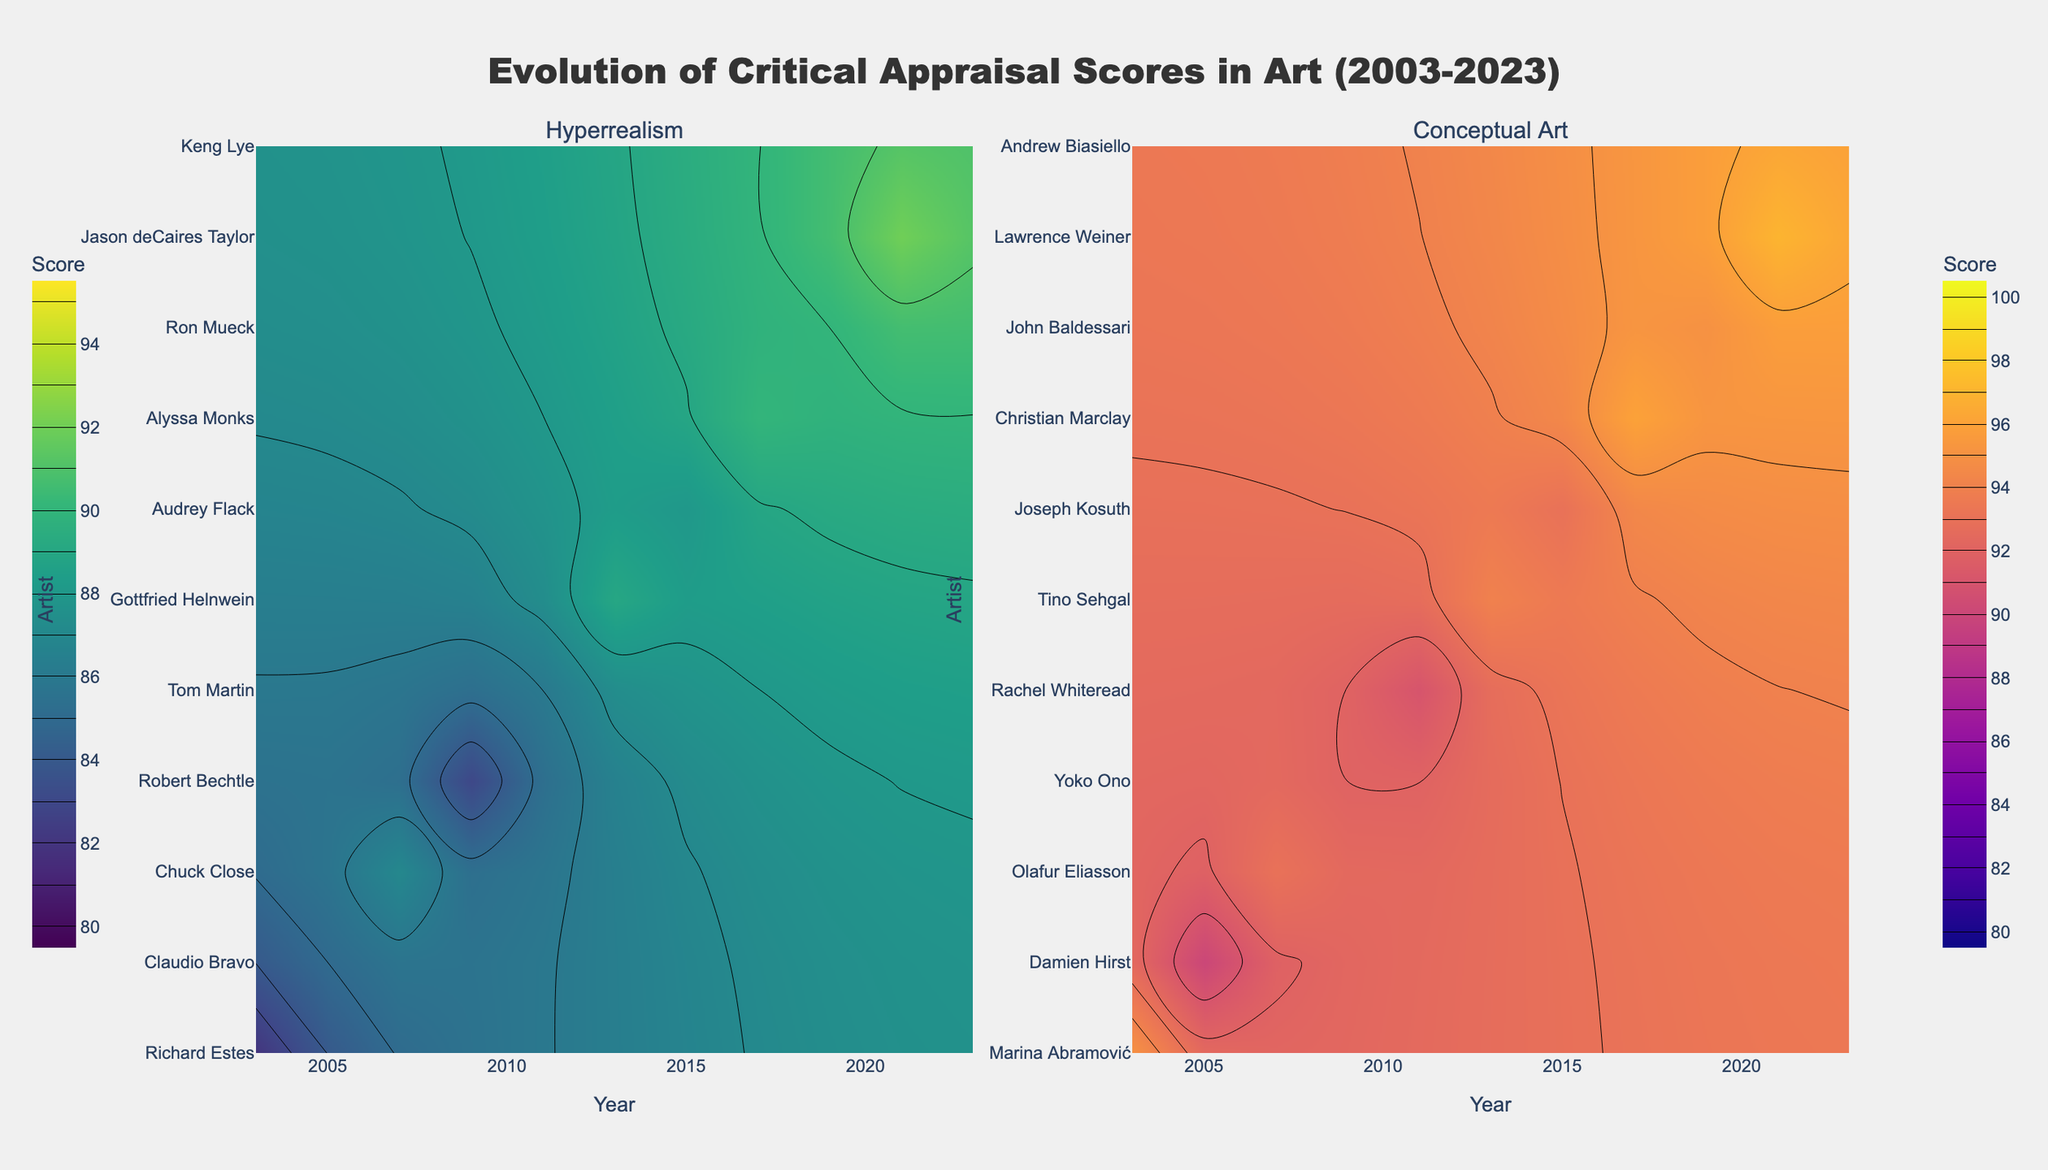What are the subplot titles in the figure? The subplot titles are present at the top of each subplot and they categorize the data into two types of art. The titles are clearly labeled and can be easily seen from the figure.
Answer: Hyperrealism and Conceptual Art What does the color scale represent in the Hyperrealism subplot? The color scale is located at the left side of the Hyperrealism subplot and indicates the range of critical appraisal scores. It shows that different shades represent different score values.
Answer: Critical appraisal scores Based on the contours, which Hyperrealism artist received the highest critical appraisal score and in which year? The contours in the Hyperrealism subplot allow us to identify the artist with the highest score by looking at the darkest area, indicating the highest score value.
Answer: Jason deCaires Taylor, 2021 Compare the overall trend of critical appraisal scores for Hyperrealism vs Conceptual Art from 2003 to 2023. Which art form tends to receive higher scores overall? Observing the color gradients and contour lines in both subplots, compare the coverage and intensity of higher score values. The Conceptual Art subplot has more intense colors in the higher range, indicating generally higher scores.
Answer: Conceptual Art What's the median score for the Hyperrealism art pieces in the figure? To determine the median score, find the middle value when the scores are arranged in ascending order. The scores for Hyperrealism pieces are: 82, 83, 85, 86, 87, 88, 89, 90, 90, 91, 92. The median is the central value.
Answer: 88 Which Conceptual Art artist received the lowest score and in which year? Analyze the Conceptual Art subplot and look for the lightest section indicating the lowest score. Locate the artist and the corresponding year in that section.
Answer: Damien Hirst, 2005 What is the average critical appraisal score for all Conceptual Art pieces? Calculate the average by summing the appraisal scores of all Conceptual Art pieces and dividing by the number of pieces. Scores: 95, 90, 93, 92, 91, 94, 93, 96, 95, 97, 96.  Sum = 932, Number of pieces = 11.  Average = 932/11
Answer: 84.73 Identify the year with the highest average critical appraisal score for Hyperrealism. For each year, sum the scores of Hyperrealism pieces and divide by the number of pieces from that year. Compare year-over-year averages to find the highest.
Answer: 2021 Which artist shows up in both subplots, indicating a transition between Hyperrealism and Conceptual Art if any? Scan both subplots to see if any artist's name appears in both, demonstrating their work in both Hyperrealism and Conceptual Art genres.
Answer: No artist appears in both subplots How does the distribution of colors differ between the Hyperrealism and Conceptual Art subplots? Compare the color patterns and intensity across both subplots. Note the range of colors used and the concentration of darker (higher value) areas.
Answer: Conceptual Art has more intense colors, showing higher values 